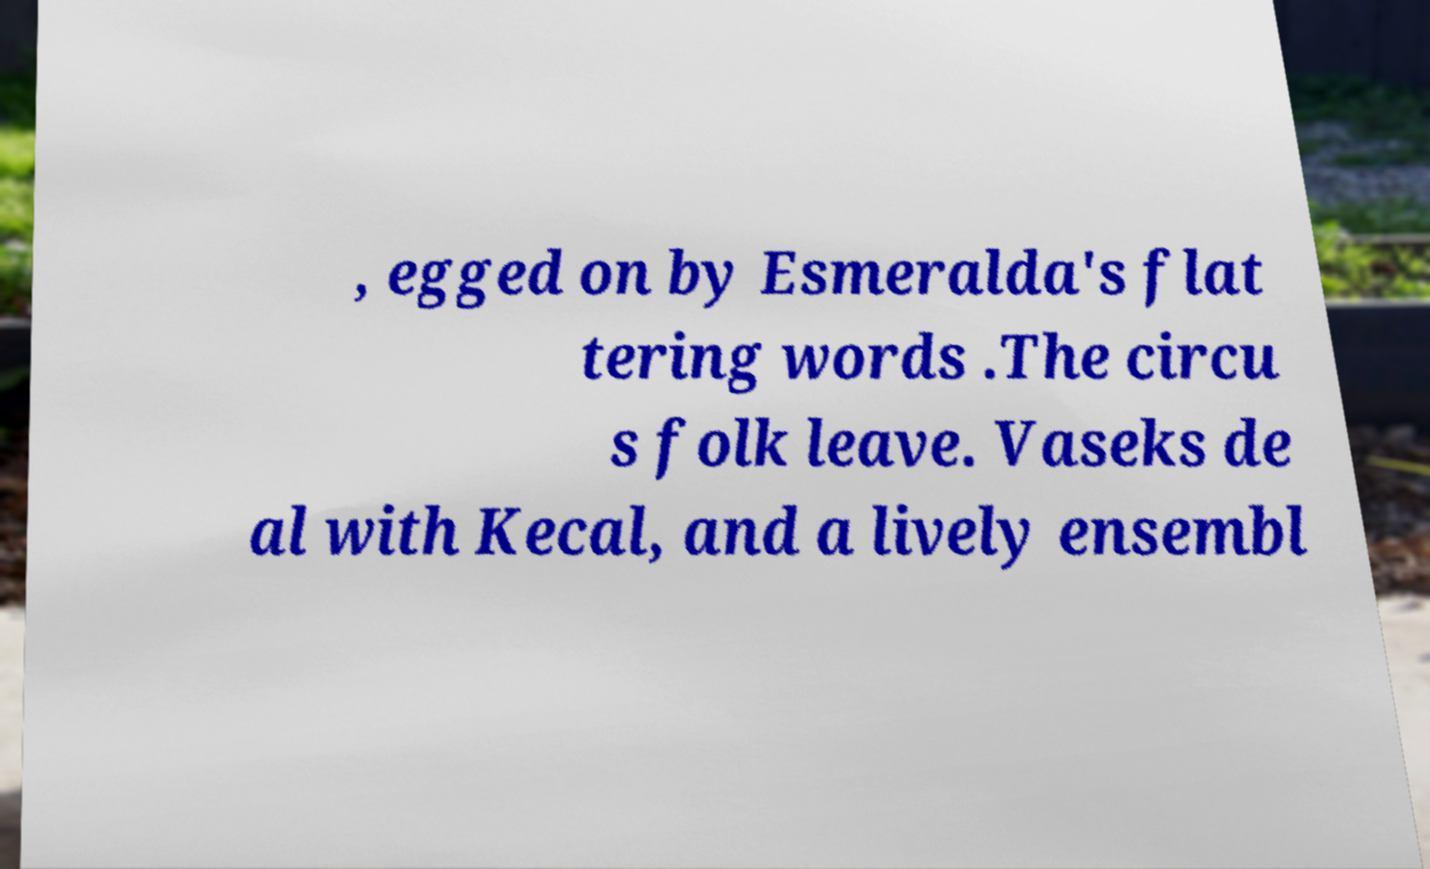For documentation purposes, I need the text within this image transcribed. Could you provide that? , egged on by Esmeralda's flat tering words .The circu s folk leave. Vaseks de al with Kecal, and a lively ensembl 